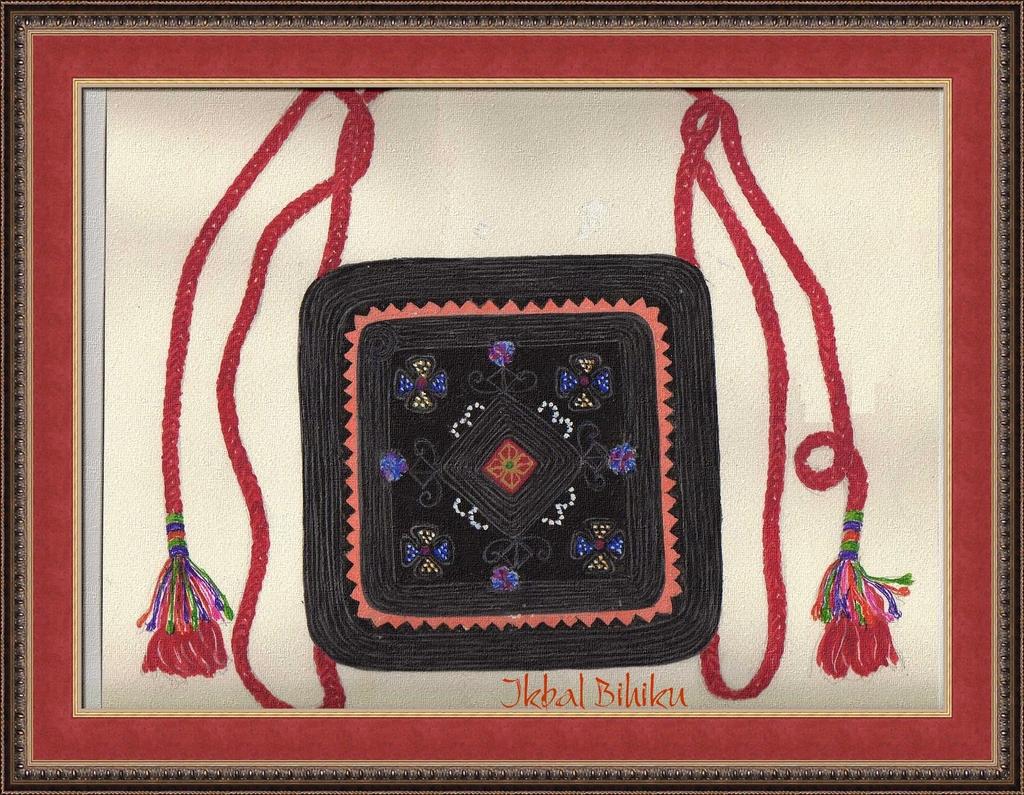What is the artist's last name?
Provide a short and direct response. Bihiku. 